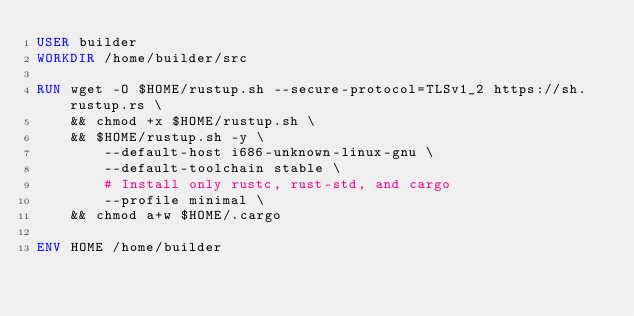Convert code to text. <code><loc_0><loc_0><loc_500><loc_500><_Dockerfile_>USER builder
WORKDIR /home/builder/src

RUN wget -O $HOME/rustup.sh --secure-protocol=TLSv1_2 https://sh.rustup.rs \
    && chmod +x $HOME/rustup.sh \
    && $HOME/rustup.sh -y \
        --default-host i686-unknown-linux-gnu \
        --default-toolchain stable \
        # Install only rustc, rust-std, and cargo
        --profile minimal \
    && chmod a+w $HOME/.cargo

ENV HOME /home/builder
</code> 